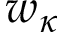<formula> <loc_0><loc_0><loc_500><loc_500>w _ { \kappa }</formula> 